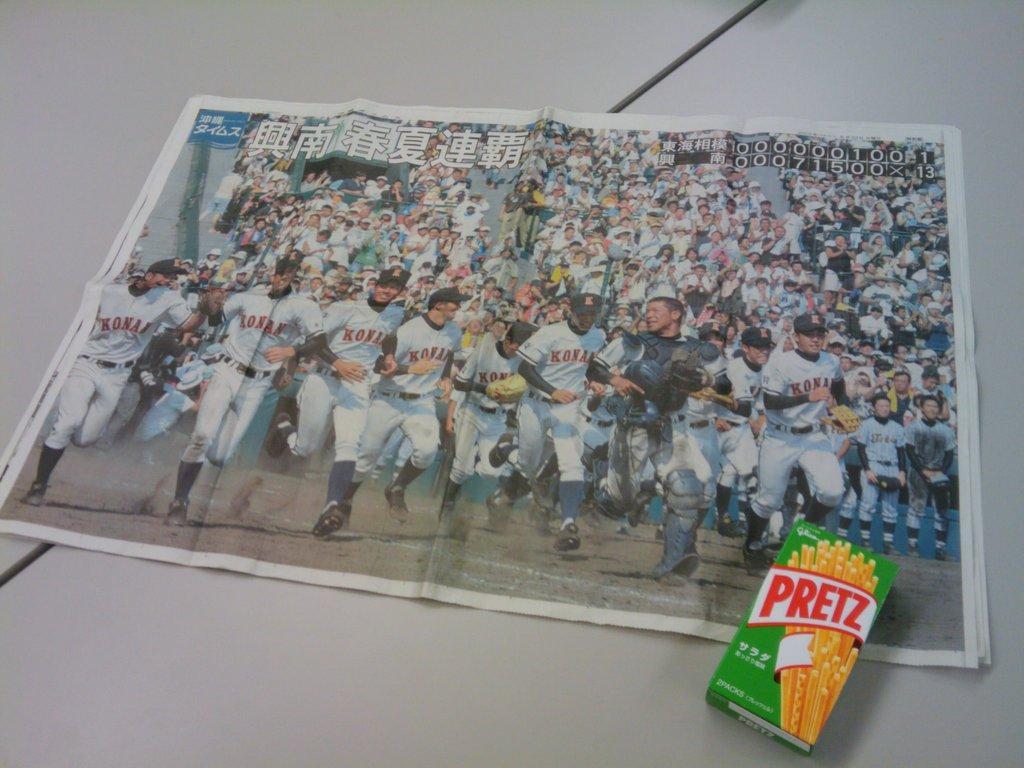Could you give a brief overview of what you see in this image? In this image we can see a paper and a carton placed on the table. 